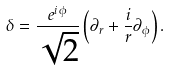Convert formula to latex. <formula><loc_0><loc_0><loc_500><loc_500>\delta = \frac { e ^ { i \, \phi } } { \sqrt { 2 } } \left ( \partial _ { r } + \frac { i } { r } \partial _ { \phi } \right ) .</formula> 